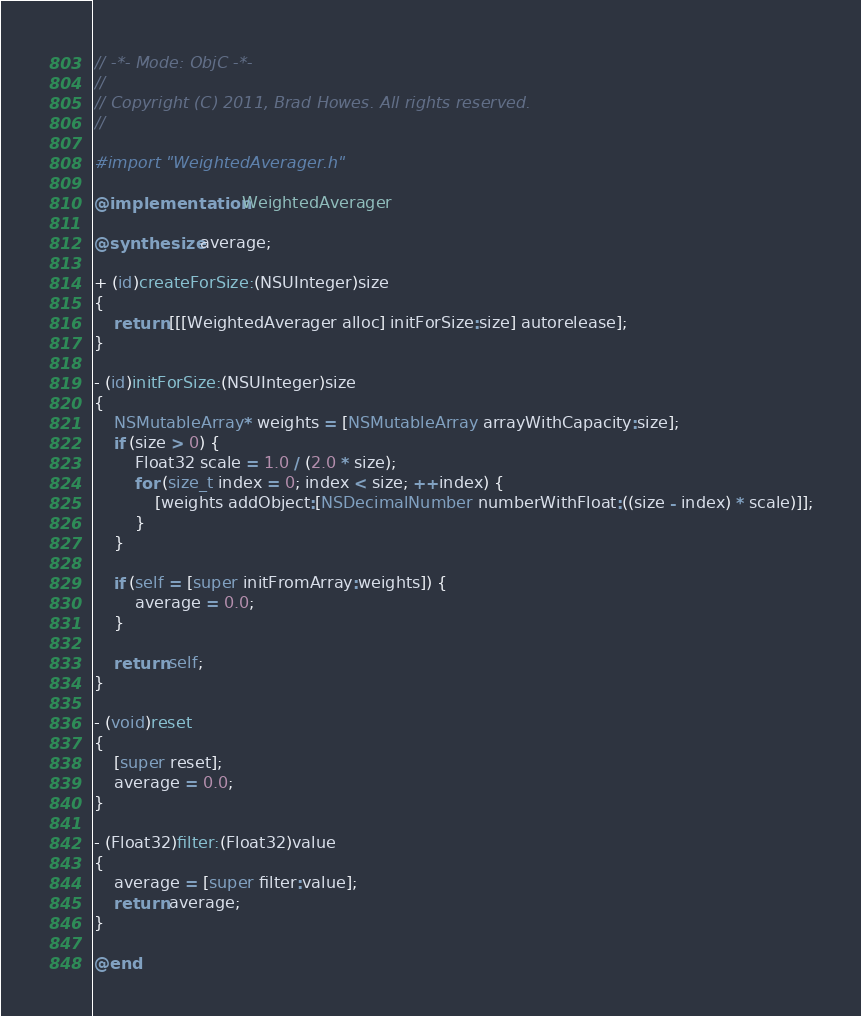<code> <loc_0><loc_0><loc_500><loc_500><_ObjectiveC_>// -*- Mode: ObjC -*-
//
// Copyright (C) 2011, Brad Howes. All rights reserved.
//

#import "WeightedAverager.h"

@implementation WeightedAverager

@synthesize average;

+ (id)createForSize:(NSUInteger)size
{
    return [[[WeightedAverager alloc] initForSize:size] autorelease];
}

- (id)initForSize:(NSUInteger)size
{
    NSMutableArray* weights = [NSMutableArray arrayWithCapacity:size];
    if (size > 0) {
        Float32 scale = 1.0 / (2.0 * size);
        for (size_t index = 0; index < size; ++index) {
            [weights addObject:[NSDecimalNumber numberWithFloat:((size - index) * scale)]];
        }
    }
    
    if (self = [super initFromArray:weights]) {
        average = 0.0;
    }
    
    return self;
}

- (void)reset
{
    [super reset];
    average = 0.0;
}

- (Float32)filter:(Float32)value
{
    average = [super filter:value];
    return average;
}

@end
</code> 